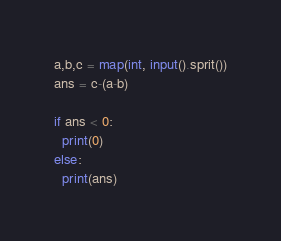<code> <loc_0><loc_0><loc_500><loc_500><_Python_>a,b,c = map(int, input().sprit())
ans = c-(a-b)

if ans < 0:
  print(0)
else:
  print(ans)</code> 